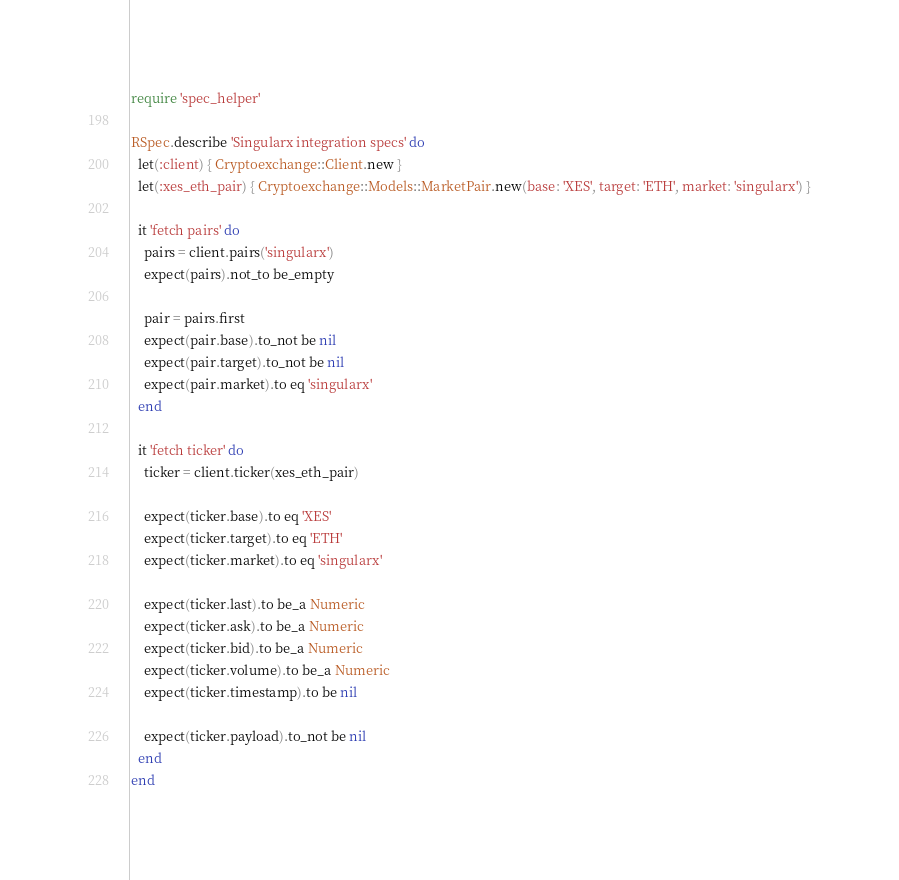<code> <loc_0><loc_0><loc_500><loc_500><_Ruby_>require 'spec_helper'

RSpec.describe 'Singularx integration specs' do
  let(:client) { Cryptoexchange::Client.new }
  let(:xes_eth_pair) { Cryptoexchange::Models::MarketPair.new(base: 'XES', target: 'ETH', market: 'singularx') }

  it 'fetch pairs' do
    pairs = client.pairs('singularx')
    expect(pairs).not_to be_empty

    pair = pairs.first
    expect(pair.base).to_not be nil
    expect(pair.target).to_not be nil
    expect(pair.market).to eq 'singularx'
  end

  it 'fetch ticker' do
    ticker = client.ticker(xes_eth_pair)

    expect(ticker.base).to eq 'XES'
    expect(ticker.target).to eq 'ETH'
    expect(ticker.market).to eq 'singularx'

    expect(ticker.last).to be_a Numeric
    expect(ticker.ask).to be_a Numeric
    expect(ticker.bid).to be_a Numeric
    expect(ticker.volume).to be_a Numeric
    expect(ticker.timestamp).to be nil
    
    expect(ticker.payload).to_not be nil
  end
end
</code> 